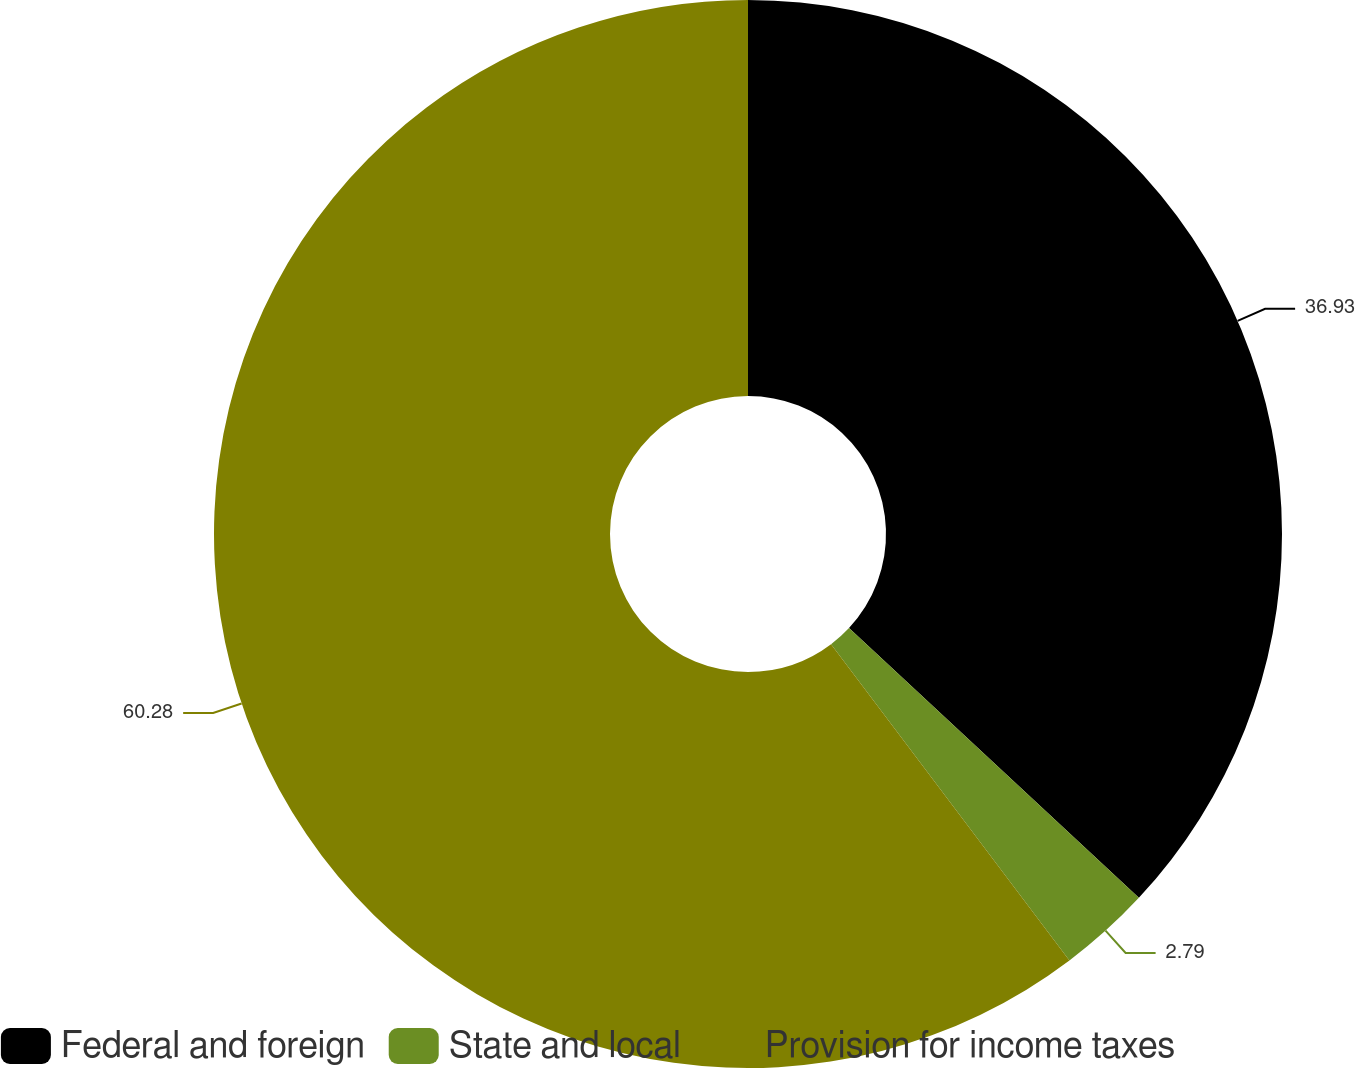Convert chart to OTSL. <chart><loc_0><loc_0><loc_500><loc_500><pie_chart><fcel>Federal and foreign<fcel>State and local<fcel>Provision for income taxes<nl><fcel>36.93%<fcel>2.79%<fcel>60.28%<nl></chart> 